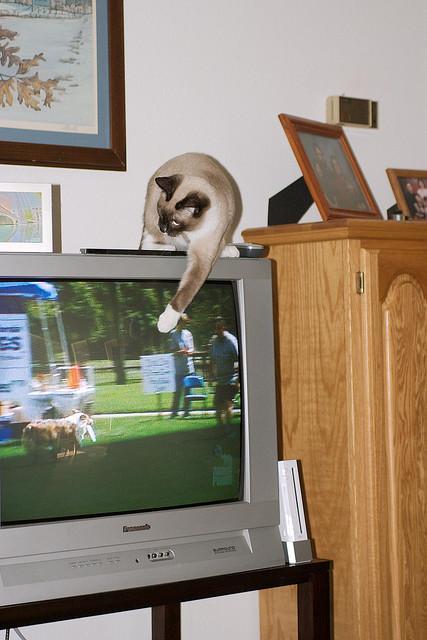How many colors is the cat?
Give a very brief answer. 2. 